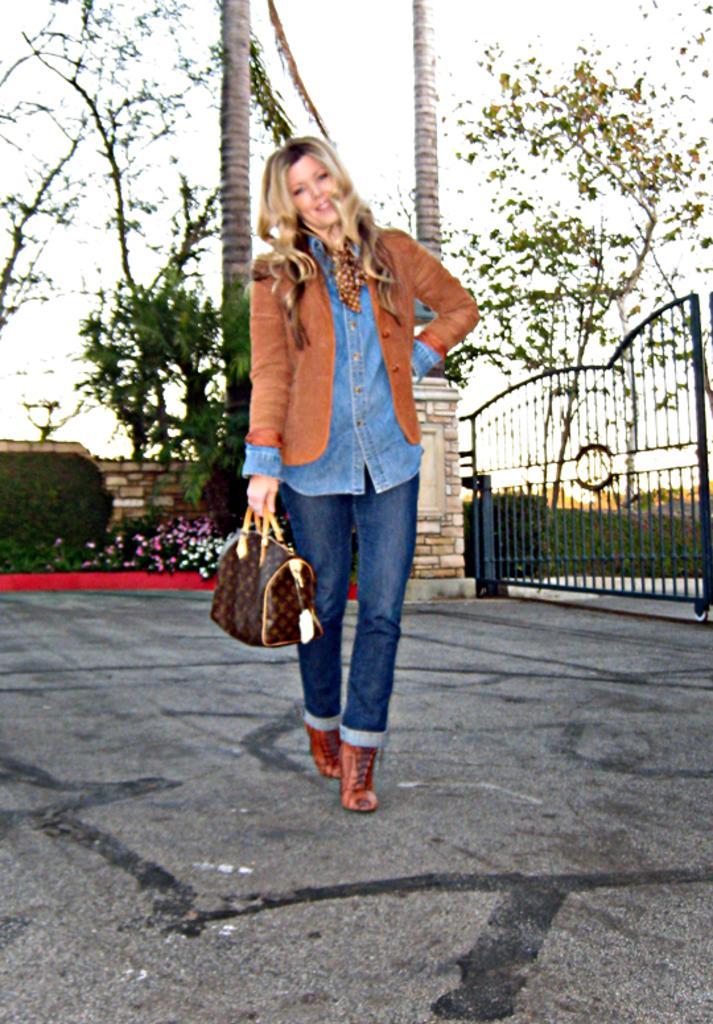In one or two sentences, can you explain what this image depicts? In this picture we can see a road on the road one lady Standing and she is holding a bag right side we can see a gate and back side there so many trees sky and plants with flowers. 